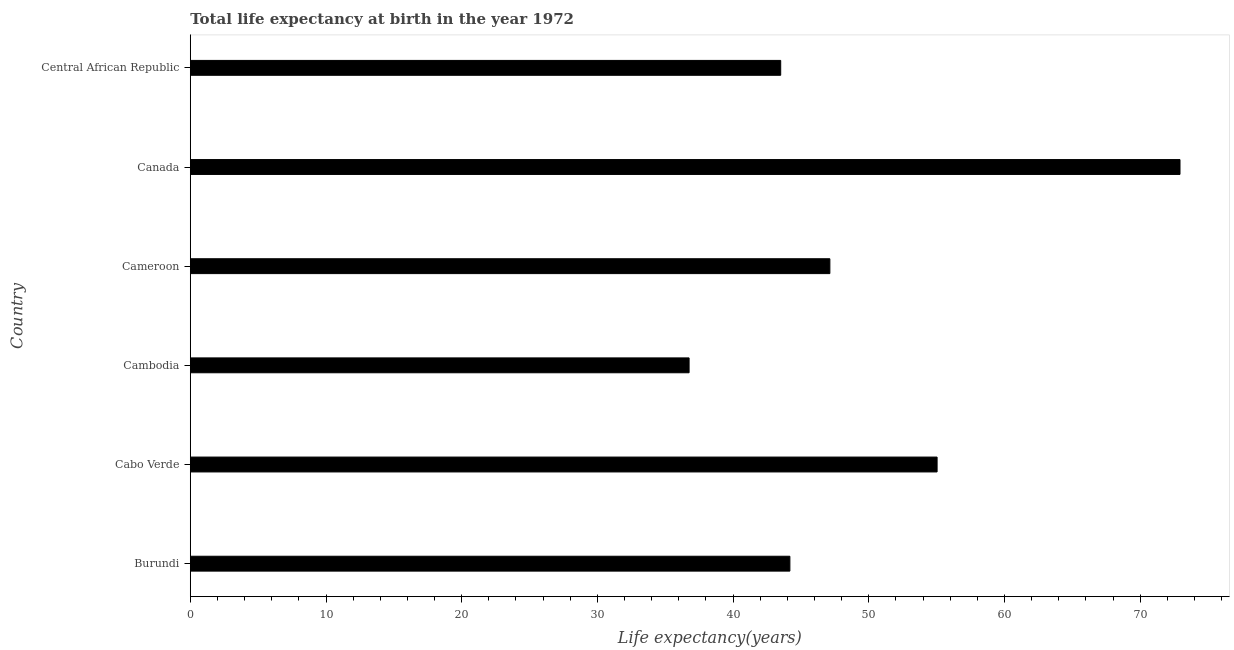Does the graph contain grids?
Make the answer very short. No. What is the title of the graph?
Offer a terse response. Total life expectancy at birth in the year 1972. What is the label or title of the X-axis?
Give a very brief answer. Life expectancy(years). What is the label or title of the Y-axis?
Provide a short and direct response. Country. What is the life expectancy at birth in Cameroon?
Keep it short and to the point. 47.13. Across all countries, what is the maximum life expectancy at birth?
Provide a succinct answer. 72.93. Across all countries, what is the minimum life expectancy at birth?
Ensure brevity in your answer.  36.76. In which country was the life expectancy at birth minimum?
Ensure brevity in your answer.  Cambodia. What is the sum of the life expectancy at birth?
Ensure brevity in your answer.  299.55. What is the difference between the life expectancy at birth in Canada and Central African Republic?
Your answer should be very brief. 29.43. What is the average life expectancy at birth per country?
Make the answer very short. 49.92. What is the median life expectancy at birth?
Your answer should be very brief. 45.66. In how many countries, is the life expectancy at birth greater than 24 years?
Give a very brief answer. 6. What is the ratio of the life expectancy at birth in Cameroon to that in Central African Republic?
Give a very brief answer. 1.08. Is the sum of the life expectancy at birth in Cabo Verde and Cameroon greater than the maximum life expectancy at birth across all countries?
Your response must be concise. Yes. What is the difference between the highest and the lowest life expectancy at birth?
Your response must be concise. 36.18. In how many countries, is the life expectancy at birth greater than the average life expectancy at birth taken over all countries?
Make the answer very short. 2. How many bars are there?
Provide a succinct answer. 6. Are all the bars in the graph horizontal?
Keep it short and to the point. Yes. How many countries are there in the graph?
Provide a short and direct response. 6. What is the difference between two consecutive major ticks on the X-axis?
Your answer should be compact. 10. What is the Life expectancy(years) in Burundi?
Provide a succinct answer. 44.18. What is the Life expectancy(years) of Cabo Verde?
Make the answer very short. 55.03. What is the Life expectancy(years) of Cambodia?
Your answer should be very brief. 36.76. What is the Life expectancy(years) of Cameroon?
Give a very brief answer. 47.13. What is the Life expectancy(years) in Canada?
Make the answer very short. 72.93. What is the Life expectancy(years) in Central African Republic?
Keep it short and to the point. 43.51. What is the difference between the Life expectancy(years) in Burundi and Cabo Verde?
Provide a short and direct response. -10.85. What is the difference between the Life expectancy(years) in Burundi and Cambodia?
Your answer should be very brief. 7.43. What is the difference between the Life expectancy(years) in Burundi and Cameroon?
Make the answer very short. -2.95. What is the difference between the Life expectancy(years) in Burundi and Canada?
Offer a terse response. -28.75. What is the difference between the Life expectancy(years) in Burundi and Central African Republic?
Your answer should be very brief. 0.68. What is the difference between the Life expectancy(years) in Cabo Verde and Cambodia?
Keep it short and to the point. 18.28. What is the difference between the Life expectancy(years) in Cabo Verde and Cameroon?
Make the answer very short. 7.9. What is the difference between the Life expectancy(years) in Cabo Verde and Canada?
Offer a very short reply. -17.9. What is the difference between the Life expectancy(years) in Cabo Verde and Central African Republic?
Give a very brief answer. 11.53. What is the difference between the Life expectancy(years) in Cambodia and Cameroon?
Give a very brief answer. -10.37. What is the difference between the Life expectancy(years) in Cambodia and Canada?
Give a very brief answer. -36.18. What is the difference between the Life expectancy(years) in Cambodia and Central African Republic?
Give a very brief answer. -6.75. What is the difference between the Life expectancy(years) in Cameroon and Canada?
Offer a very short reply. -25.8. What is the difference between the Life expectancy(years) in Cameroon and Central African Republic?
Offer a terse response. 3.62. What is the difference between the Life expectancy(years) in Canada and Central African Republic?
Your answer should be compact. 29.43. What is the ratio of the Life expectancy(years) in Burundi to that in Cabo Verde?
Your answer should be compact. 0.8. What is the ratio of the Life expectancy(years) in Burundi to that in Cambodia?
Ensure brevity in your answer.  1.2. What is the ratio of the Life expectancy(years) in Burundi to that in Cameroon?
Give a very brief answer. 0.94. What is the ratio of the Life expectancy(years) in Burundi to that in Canada?
Provide a short and direct response. 0.61. What is the ratio of the Life expectancy(years) in Burundi to that in Central African Republic?
Your response must be concise. 1.02. What is the ratio of the Life expectancy(years) in Cabo Verde to that in Cambodia?
Make the answer very short. 1.5. What is the ratio of the Life expectancy(years) in Cabo Verde to that in Cameroon?
Offer a very short reply. 1.17. What is the ratio of the Life expectancy(years) in Cabo Verde to that in Canada?
Keep it short and to the point. 0.76. What is the ratio of the Life expectancy(years) in Cabo Verde to that in Central African Republic?
Your answer should be very brief. 1.26. What is the ratio of the Life expectancy(years) in Cambodia to that in Cameroon?
Offer a terse response. 0.78. What is the ratio of the Life expectancy(years) in Cambodia to that in Canada?
Provide a succinct answer. 0.5. What is the ratio of the Life expectancy(years) in Cambodia to that in Central African Republic?
Provide a succinct answer. 0.84. What is the ratio of the Life expectancy(years) in Cameroon to that in Canada?
Make the answer very short. 0.65. What is the ratio of the Life expectancy(years) in Cameroon to that in Central African Republic?
Make the answer very short. 1.08. What is the ratio of the Life expectancy(years) in Canada to that in Central African Republic?
Keep it short and to the point. 1.68. 